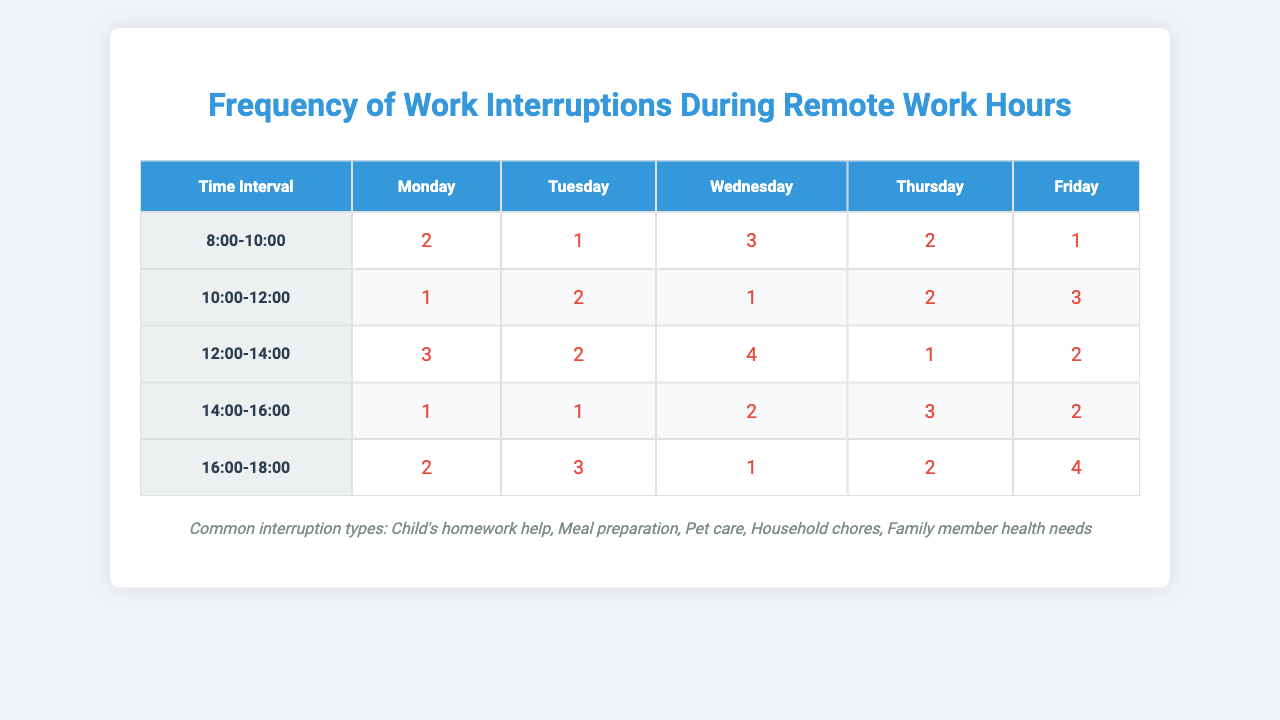What is the most frequent interruption type on Wednesday between 12:00 and 14:00? From the table, on Wednesday, the interruptions for the time interval 12:00 to 14:00 are recorded as 4. Since the interruption types are not directly correlated to specific counts in this context, we just note the type was not specified but rather the time interval had the most interruptions.
Answer: 4 How many interruptions occurred on Friday from 14:00 to 16:00? Looking at the table, the value for Friday in the 14:00 to 16:00 time slot is 2. Therefore, that is the number of interruptions for that time.
Answer: 2 What is the total number of interruptions recorded on Tuesday? To find the total interruptions on Tuesday, we add the interruptions for all time intervals: 1 + 2 + 2 + 1 + 3 = 9. This gives us the total for the day.
Answer: 9 Which day had the highest total number of interruptions across all time periods? Adding the interruptions for each day: Monday (9), Tuesday (9), Wednesday (11), Thursday (10), Friday (12). The highest total is for Friday, which sums to 12.
Answer: Friday What is the average number of interruptions across all time slots on Monday? For Monday, the interruptions are 2, 1, 3, 1, and 2. Adding these gives 2 + 1 + 3 + 1 + 2 = 9. There are 5 time intervals, so the average is 9/5 = 1.8.
Answer: 1.8 Is it true that the maximum interruptions occur at the same time interval every day? By examining the table, the maximum interruptions do not occur in the same time slot each day; they vary across different days. For example, Wednesday has the highest in the 12:00-14:00 period, while Friday's highest is in the 16:00-18:00 period.
Answer: No What is the frequency of interruptions during the early morning hours (8:00 to 10:00) for the week? Summing the interruptions for the 8:00 to 10:00 time interval: Monday (2), Tuesday (1), Wednesday (3), Thursday (2), Friday (1) gives a total of 2 + 1 + 3 + 2 + 1 = 9.
Answer: 9 On which day is the interruption count for the time slot 10:00 to 12:00 highest? The values in that slot are: Monday (1), Tuesday (2), Wednesday (1), Thursday (2), Friday (3). The highest value for that slot is on Friday with 3 interruptions.
Answer: Friday What is the difference in interruptions between Thursday and Friday from 16:00 to 18:00? The interruptions for Thursday in this time slot is 2 and for Friday is 4. Therefore, the difference is 4 - 2 = 2.
Answer: 2 How many times did interruptions due to “Child's homework help” occur on Wednesday between 8:00 and 10:00? The table does not specify the type of interruptions associated with each count directly; thus, we can only provide the total interruptions for the time slot, which is 3. The type cannot be confirmed for this specific count without additional information.
Answer: 3 (note: type details not specified for precise answer) 